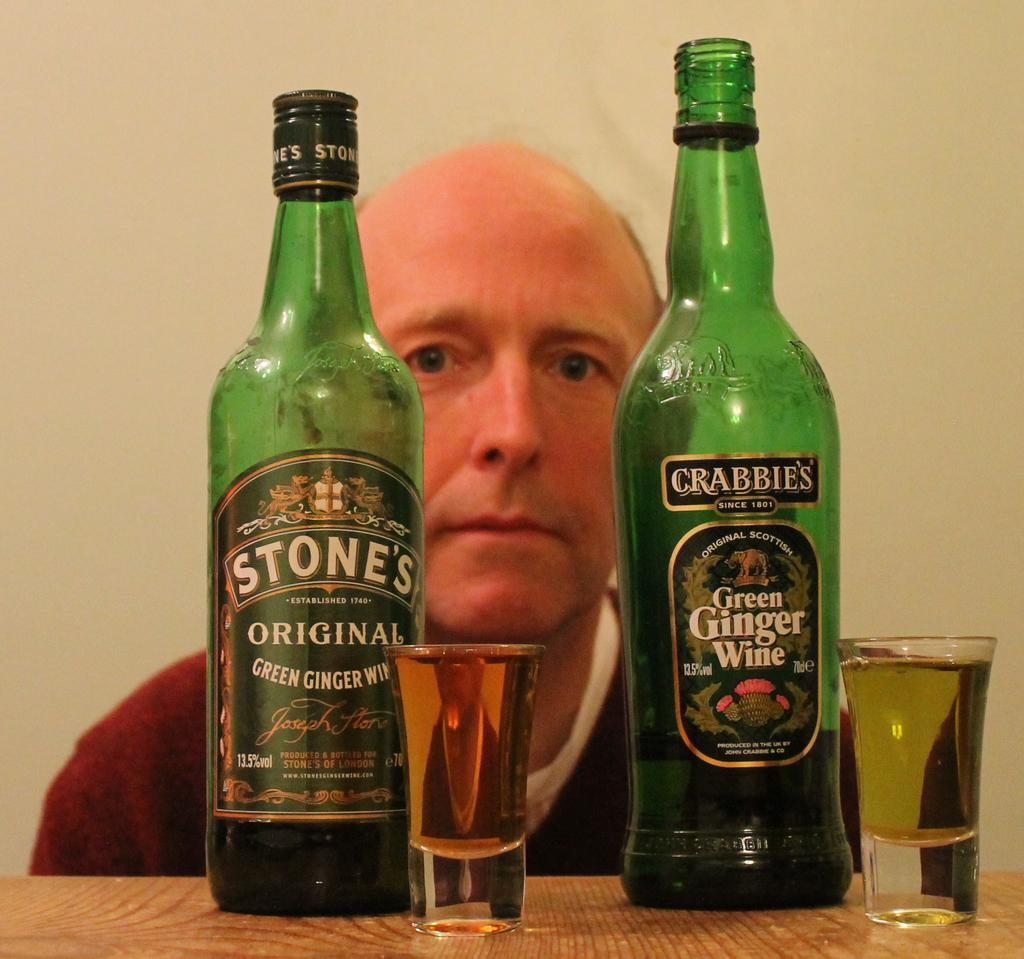<image>
Share a concise interpretation of the image provided. Stone's Original Green Ginger Wine is labeled on these bottles. 